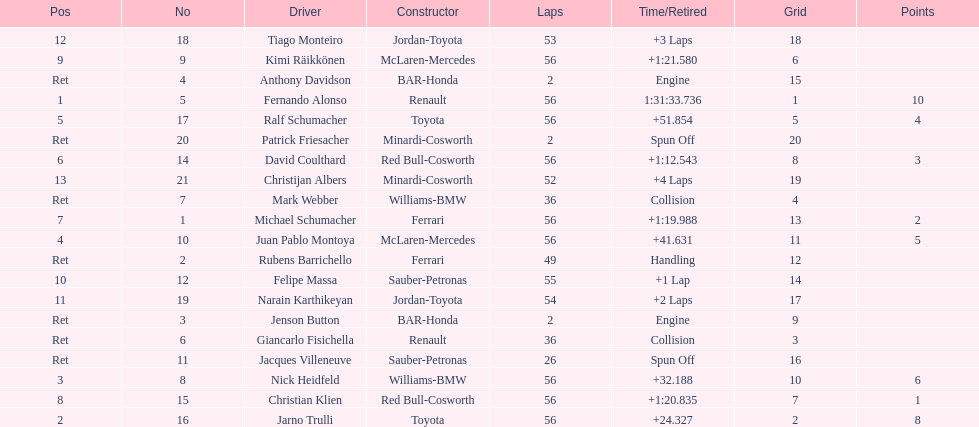What driver finished first? Fernando Alonso. 